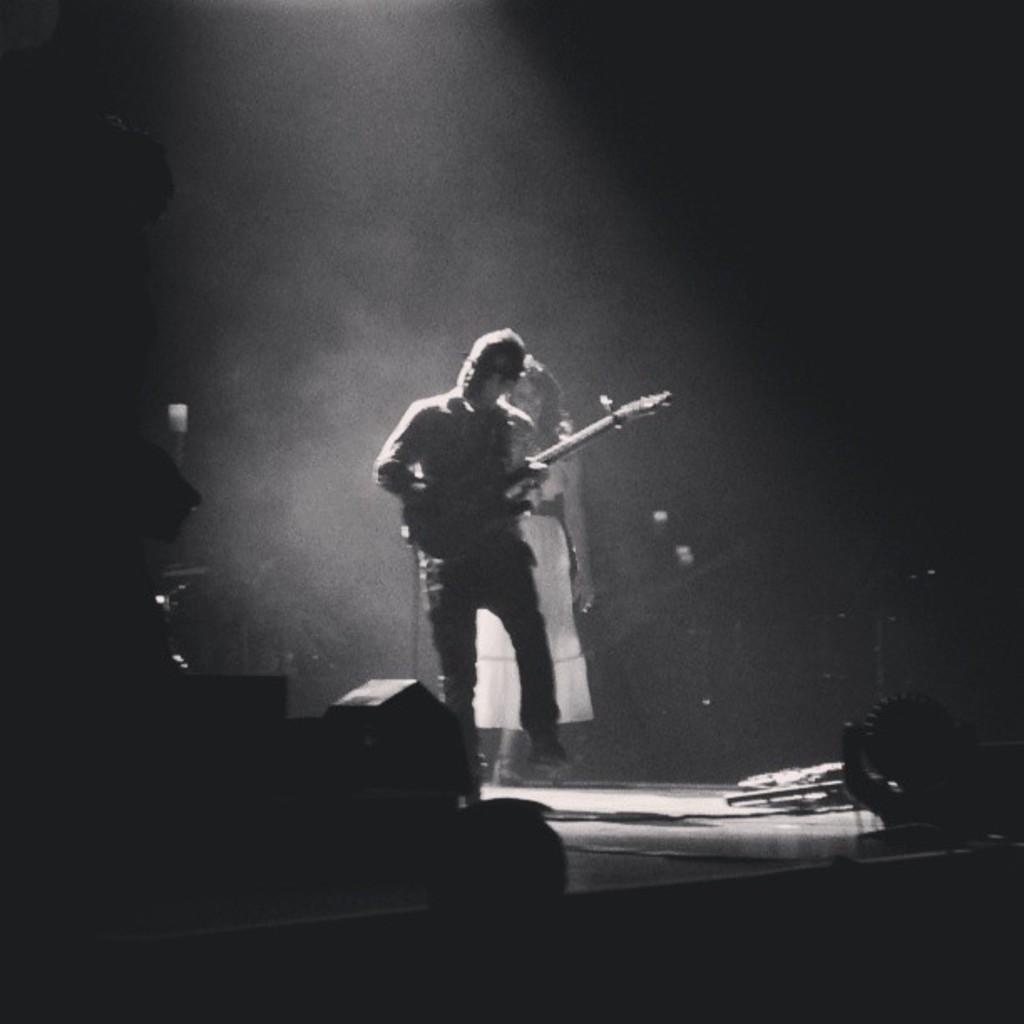How many people are in the image? There are two people in the image, a man and a woman. What is the man holding in the image? The man is holding a guitar. What is the woman doing in the image? The facts provided do not specify what the woman is doing in the image. What type of potato is being used as a prop in the image? There is no potato present in the image. What is the purpose of the coast in the image? There is no coast present in the image. 